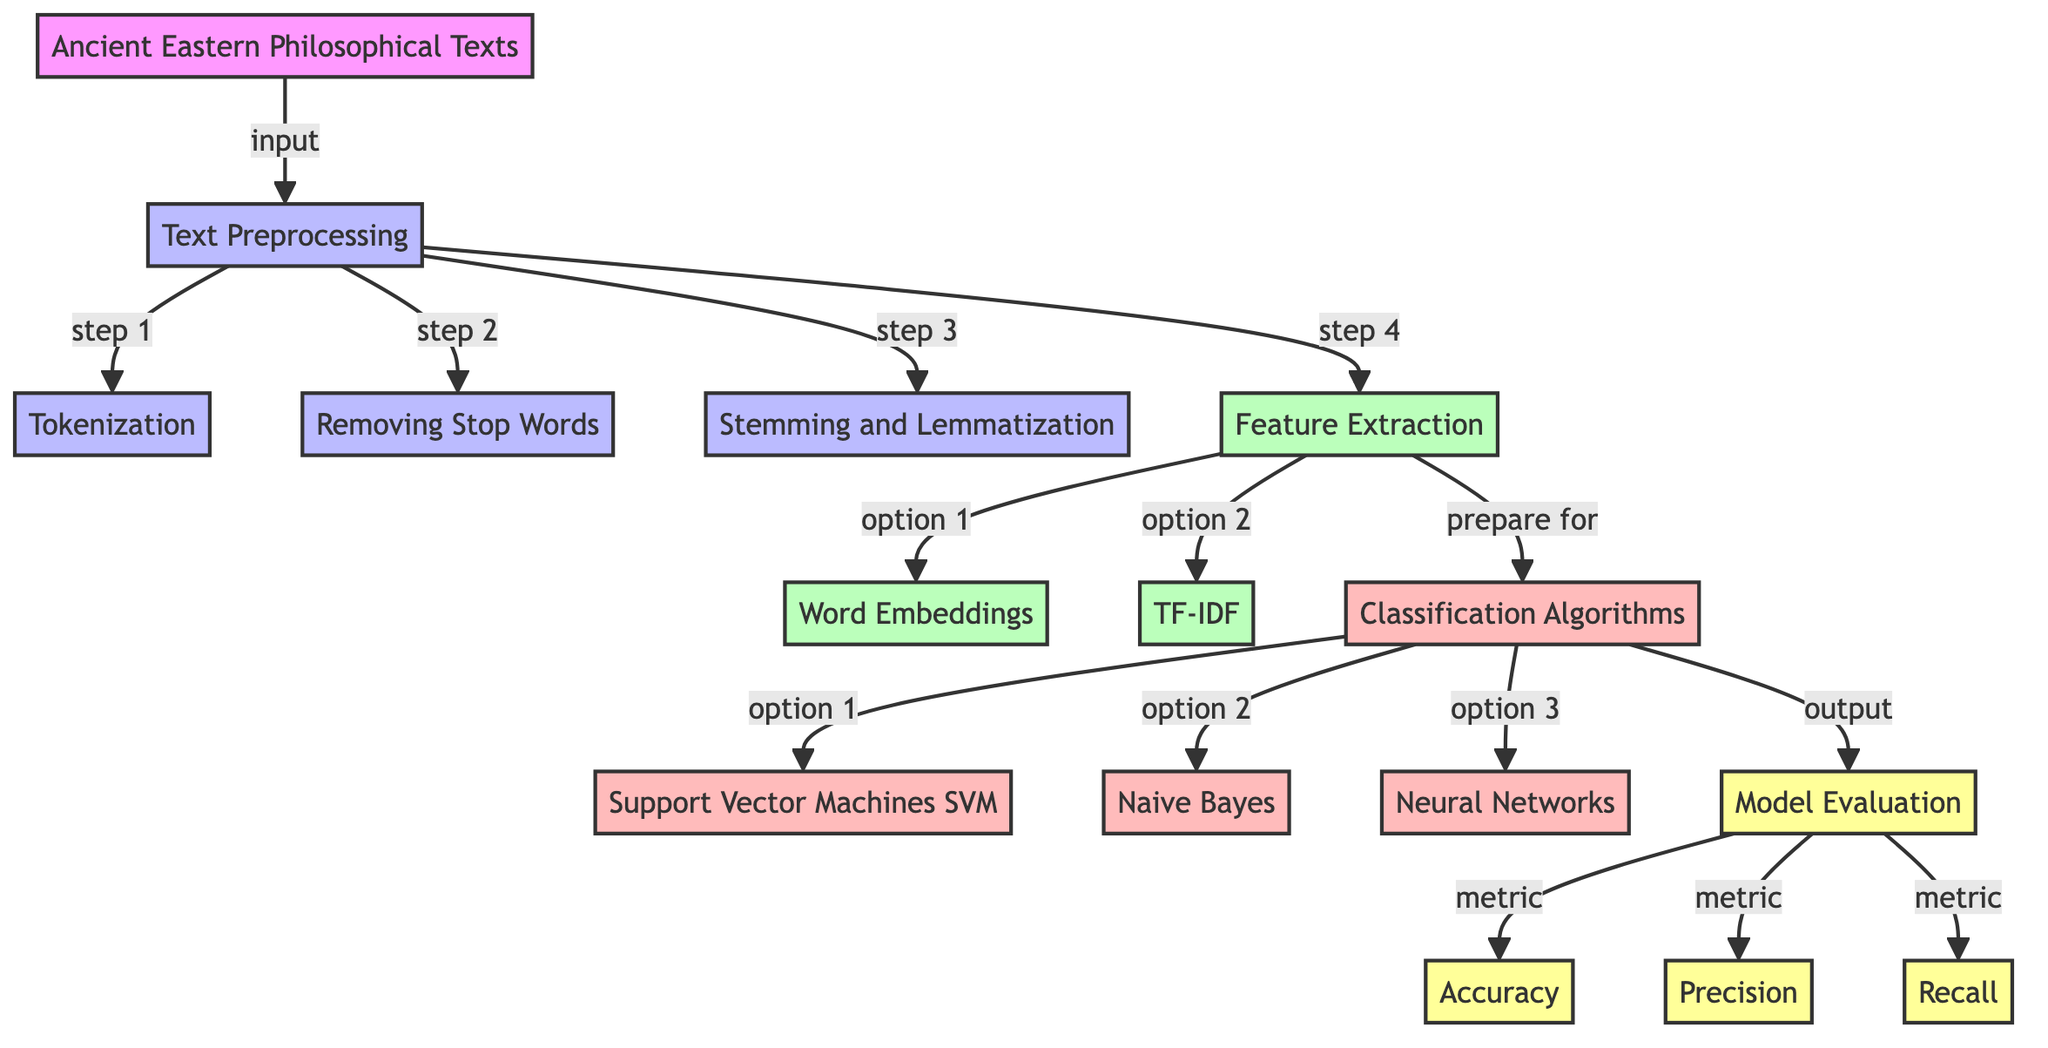What is the first step after inputting the texts? The diagram indicates that the first step after inputting the ancient Eastern philosophical texts is "Text Preprocessing", which is the node directly connected to the input node.
Answer: Text Preprocessing How many methods are listed under Classification Algorithms? There are three methods listed under the Classification Algorithms node: Support Vector Machines, Naive Bayes, and Neural Networks. Counting these options indicates a total of three.
Answer: Three What are the two options for feature extraction? The options for feature extraction in the diagram are "Word Embeddings" and "TF-IDF", which are the two branches under the Feature Extraction node.
Answer: Word Embeddings and TF-IDF Which evaluation metrics come after Model Evaluation? The evaluation metrics that come after Model Evaluation are Accuracy, Precision, and Recall, as these nodes branch out from the Model Evaluation node.
Answer: Accuracy, Precision, Recall What is the relationship between Text Preprocessing and Feature Extraction? Text Preprocessing leads directly to Feature Extraction; after preprocessing the texts, feature extraction is the next step in the flow of the diagram.
Answer: Directly connected Which step comes before the classification algorithms? The step that comes immediately before the Classification Algorithms is Feature Extraction, as it supplies the necessary features required for classification.
Answer: Feature Extraction Which process is indicated by step 3 in the diagram? Step 3 in the diagram refers to "Stemming and Lemmatization", which is part of the preprocessing steps used to prepare the text data.
Answer: Stemming and Lemmatization What is the final output of the diagram? The final output of the diagram is "Model Evaluation", as it is the last node reached after processing and classification, representing the final assessment of the model's performance.
Answer: Model Evaluation 